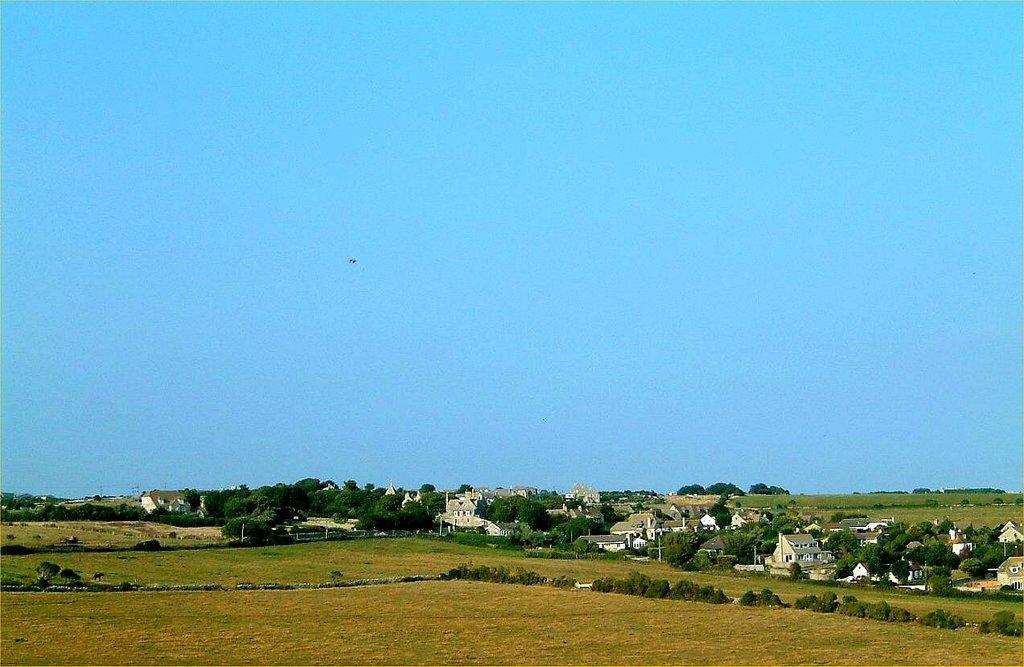What type of vegetation can be seen in the image? There are trees and plants in the image. What type of structures are present in the image? There are buildings in the image. What is covering the ground in the image? There is grass on the ground in the image. What color is the sky in the background of the image? The sky is blue in the background of the image. What type of disease is affecting the trees in the image? There is no indication of any disease affecting the trees in the image; they appear healthy. Does the existence of the buildings in the image prove the existence of extraterrestrial life? The presence of buildings in the image does not prove the existence of extraterrestrial life; it only shows the presence of human-made structures. 